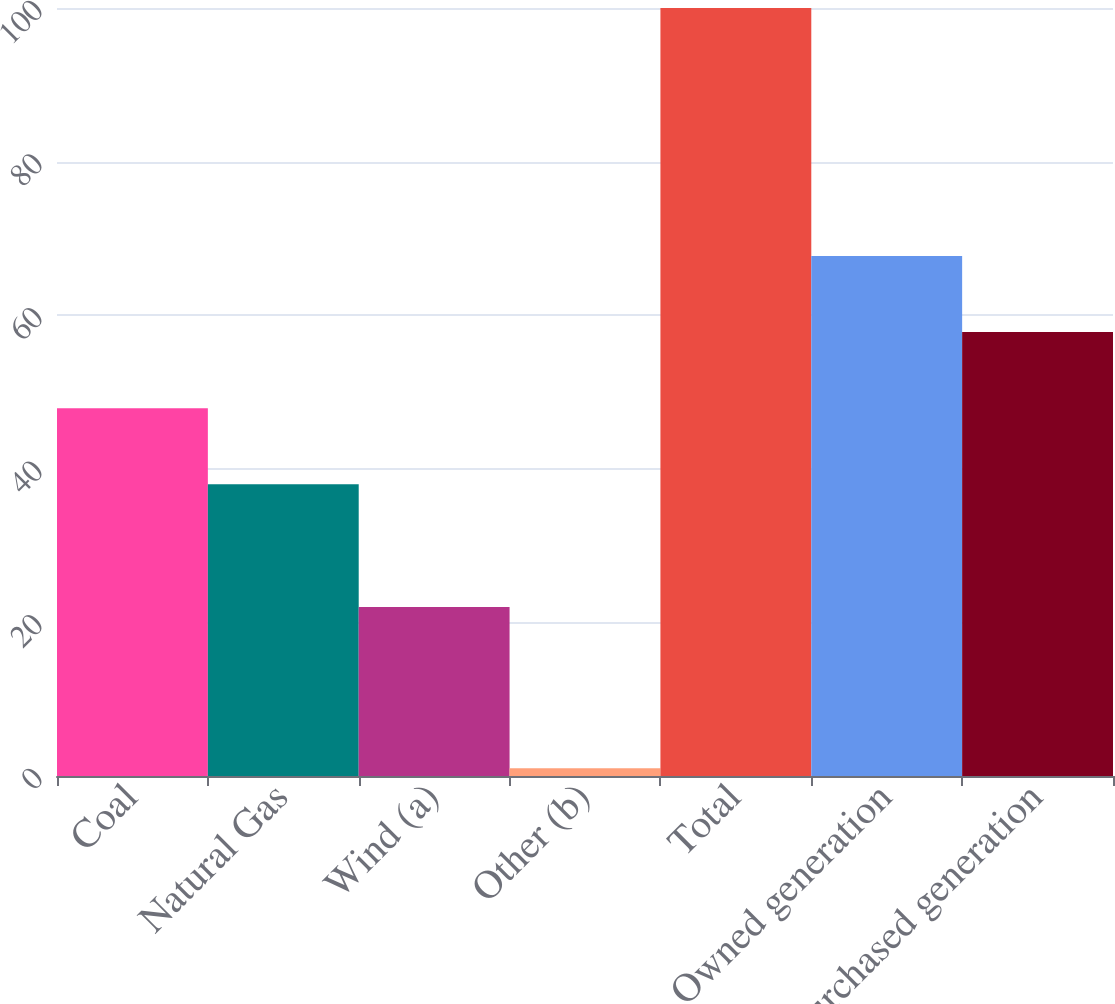Convert chart. <chart><loc_0><loc_0><loc_500><loc_500><bar_chart><fcel>Coal<fcel>Natural Gas<fcel>Wind (a)<fcel>Other (b)<fcel>Total<fcel>Owned generation<fcel>Purchased generation<nl><fcel>47.9<fcel>38<fcel>22<fcel>1<fcel>100<fcel>67.7<fcel>57.8<nl></chart> 